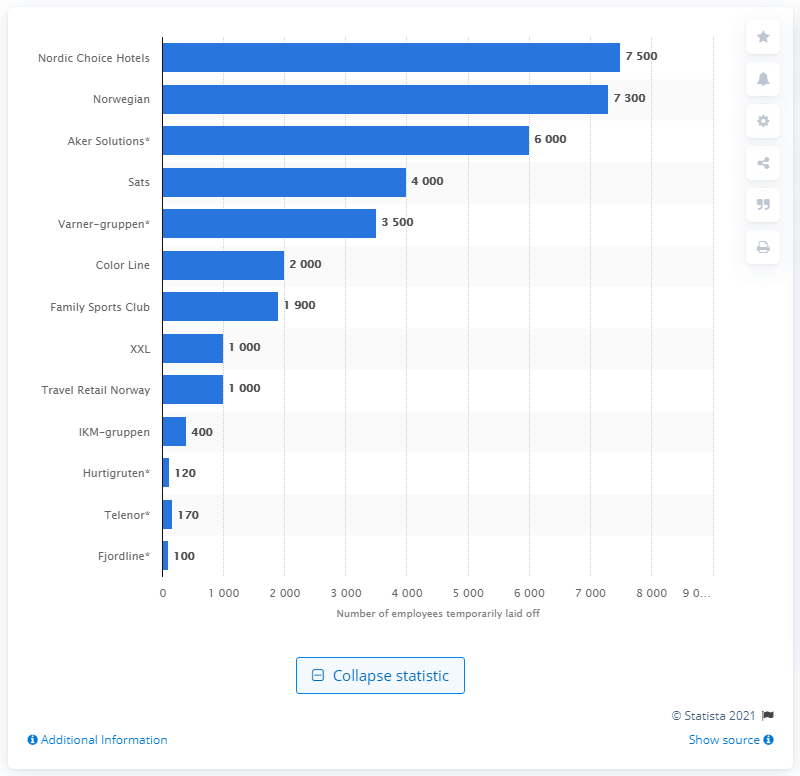Indicate a few pertinent items in this graphic. A leading hotel chain in the Nordic and Baltic regions laid off approximately 7,500 employees. Nordic Choice Hotels is the leading hotel chain in the Nordic and Baltic regions. 